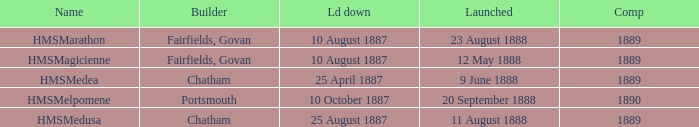What is the name of the boat that was built by Chatham and Laid down of 25 april 1887? HMSMedea. Could you parse the entire table as a dict? {'header': ['Name', 'Builder', 'Ld down', 'Launched', 'Comp'], 'rows': [['HMSMarathon', 'Fairfields, Govan', '10 August 1887', '23 August 1888', '1889'], ['HMSMagicienne', 'Fairfields, Govan', '10 August 1887', '12 May 1888', '1889'], ['HMSMedea', 'Chatham', '25 April 1887', '9 June 1888', '1889'], ['HMSMelpomene', 'Portsmouth', '10 October 1887', '20 September 1888', '1890'], ['HMSMedusa', 'Chatham', '25 August 1887', '11 August 1888', '1889']]} 